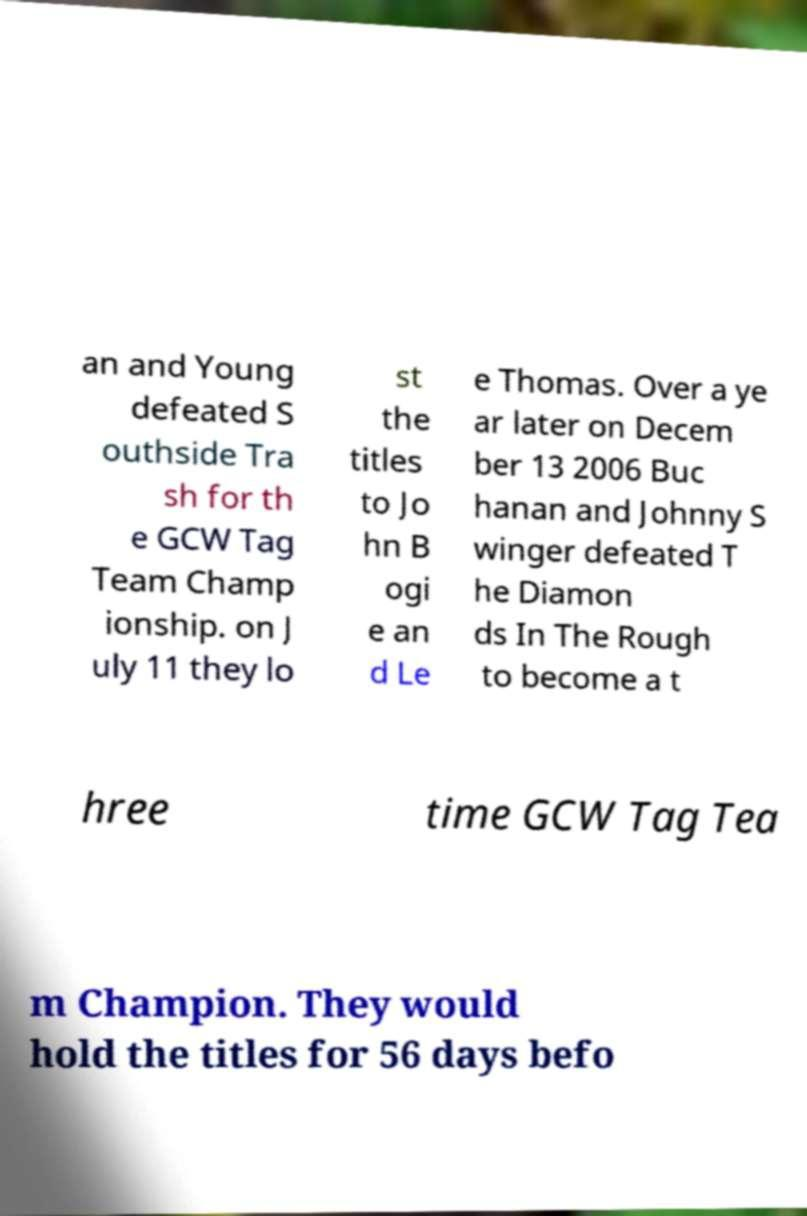Please identify and transcribe the text found in this image. an and Young defeated S outhside Tra sh for th e GCW Tag Team Champ ionship. on J uly 11 they lo st the titles to Jo hn B ogi e an d Le e Thomas. Over a ye ar later on Decem ber 13 2006 Buc hanan and Johnny S winger defeated T he Diamon ds In The Rough to become a t hree time GCW Tag Tea m Champion. They would hold the titles for 56 days befo 